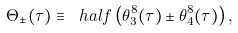Convert formula to latex. <formula><loc_0><loc_0><loc_500><loc_500>\Theta _ { \pm } ( \tau ) \equiv \ h a l f \left ( \theta _ { 3 } ^ { 8 } ( \tau ) \pm \theta _ { 4 } ^ { 8 } ( \tau ) \right ) ,</formula> 